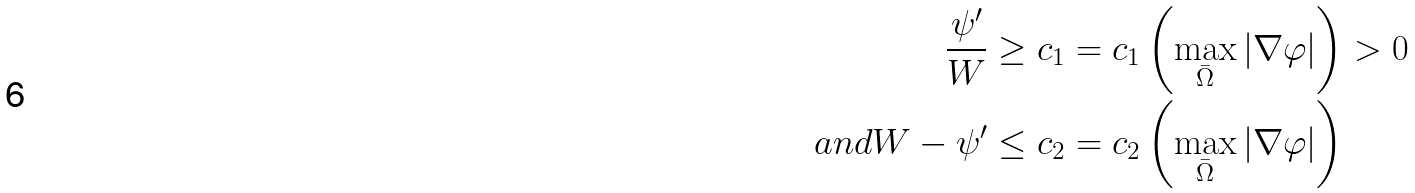<formula> <loc_0><loc_0><loc_500><loc_500>\frac { \psi ^ { \prime } } { W } & \geq c _ { 1 } = c _ { 1 } \left ( \max _ { \bar { \Omega } } | \nabla \varphi | \right ) > 0 \\ { a n d } W - \psi ^ { \prime } & \leq c _ { 2 } = c _ { 2 } \left ( \max _ { \bar { \Omega } } | \nabla \varphi | \right )</formula> 